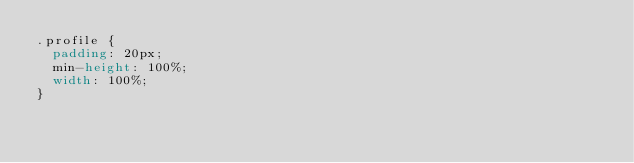Convert code to text. <code><loc_0><loc_0><loc_500><loc_500><_CSS_>.profile {
	padding: 20px;
	min-height: 100%;
	width: 100%;
}
</code> 